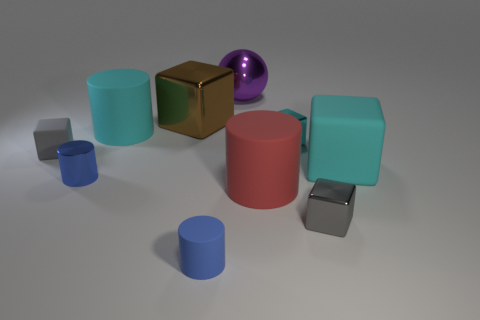What color is the large matte cylinder that is to the right of the big cube behind the big rubber object that is behind the tiny gray matte cube?
Make the answer very short. Red. What number of blocks are blue rubber objects or tiny shiny things?
Your answer should be very brief. 2. What material is the small thing that is the same color as the tiny rubber cylinder?
Make the answer very short. Metal. There is a tiny rubber block; is it the same color as the metal thing in front of the red thing?
Your answer should be very brief. Yes. The ball has what color?
Offer a terse response. Purple. How many objects are metallic objects or large cyan matte cylinders?
Your answer should be compact. 6. There is a cyan thing that is the same size as the gray metallic object; what is it made of?
Your answer should be compact. Metal. There is a metallic thing on the right side of the small cyan thing; how big is it?
Keep it short and to the point. Small. What is the sphere made of?
Offer a very short reply. Metal. What number of things are either objects that are to the right of the large cyan cylinder or small blue objects in front of the small gray metallic thing?
Your answer should be compact. 7. 